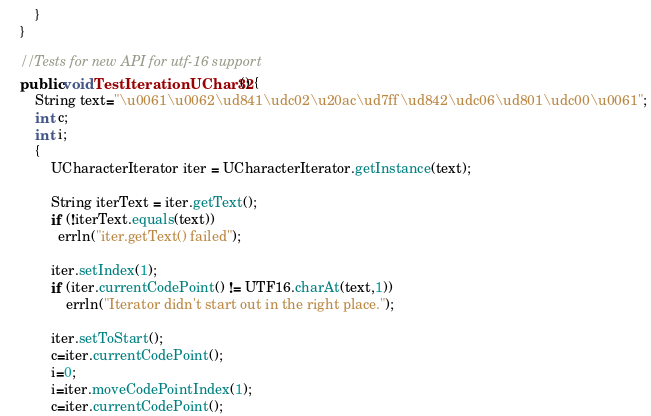<code> <loc_0><loc_0><loc_500><loc_500><_Java_>        }
    }
    
    //Tests for new API for utf-16 support 
    public void TestIterationUChar32() {
        String text="\u0061\u0062\ud841\udc02\u20ac\ud7ff\ud842\udc06\ud801\udc00\u0061";
        int c;
        int i;
        {
            UCharacterIterator iter = UCharacterIterator.getInstance(text);
    
            String iterText = iter.getText();
            if (!iterText.equals(text))
              errln("iter.getText() failed");
            
            iter.setIndex(1);
            if (iter.currentCodePoint() != UTF16.charAt(text,1))
                errln("Iterator didn't start out in the right place.");
    
            iter.setToStart();
            c=iter.currentCodePoint();
            i=0;
            i=iter.moveCodePointIndex(1);
            c=iter.currentCodePoint();</code> 